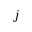Convert formula to latex. <formula><loc_0><loc_0><loc_500><loc_500>j</formula> 